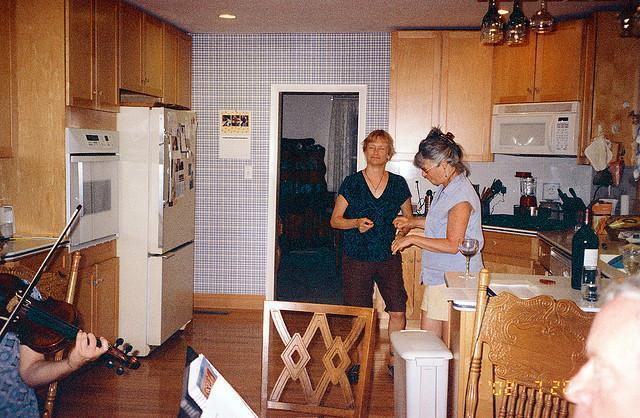How many people are there?
Give a very brief answer. 4. How many chairs are visible?
Give a very brief answer. 2. How many bananas are shown?
Give a very brief answer. 0. 